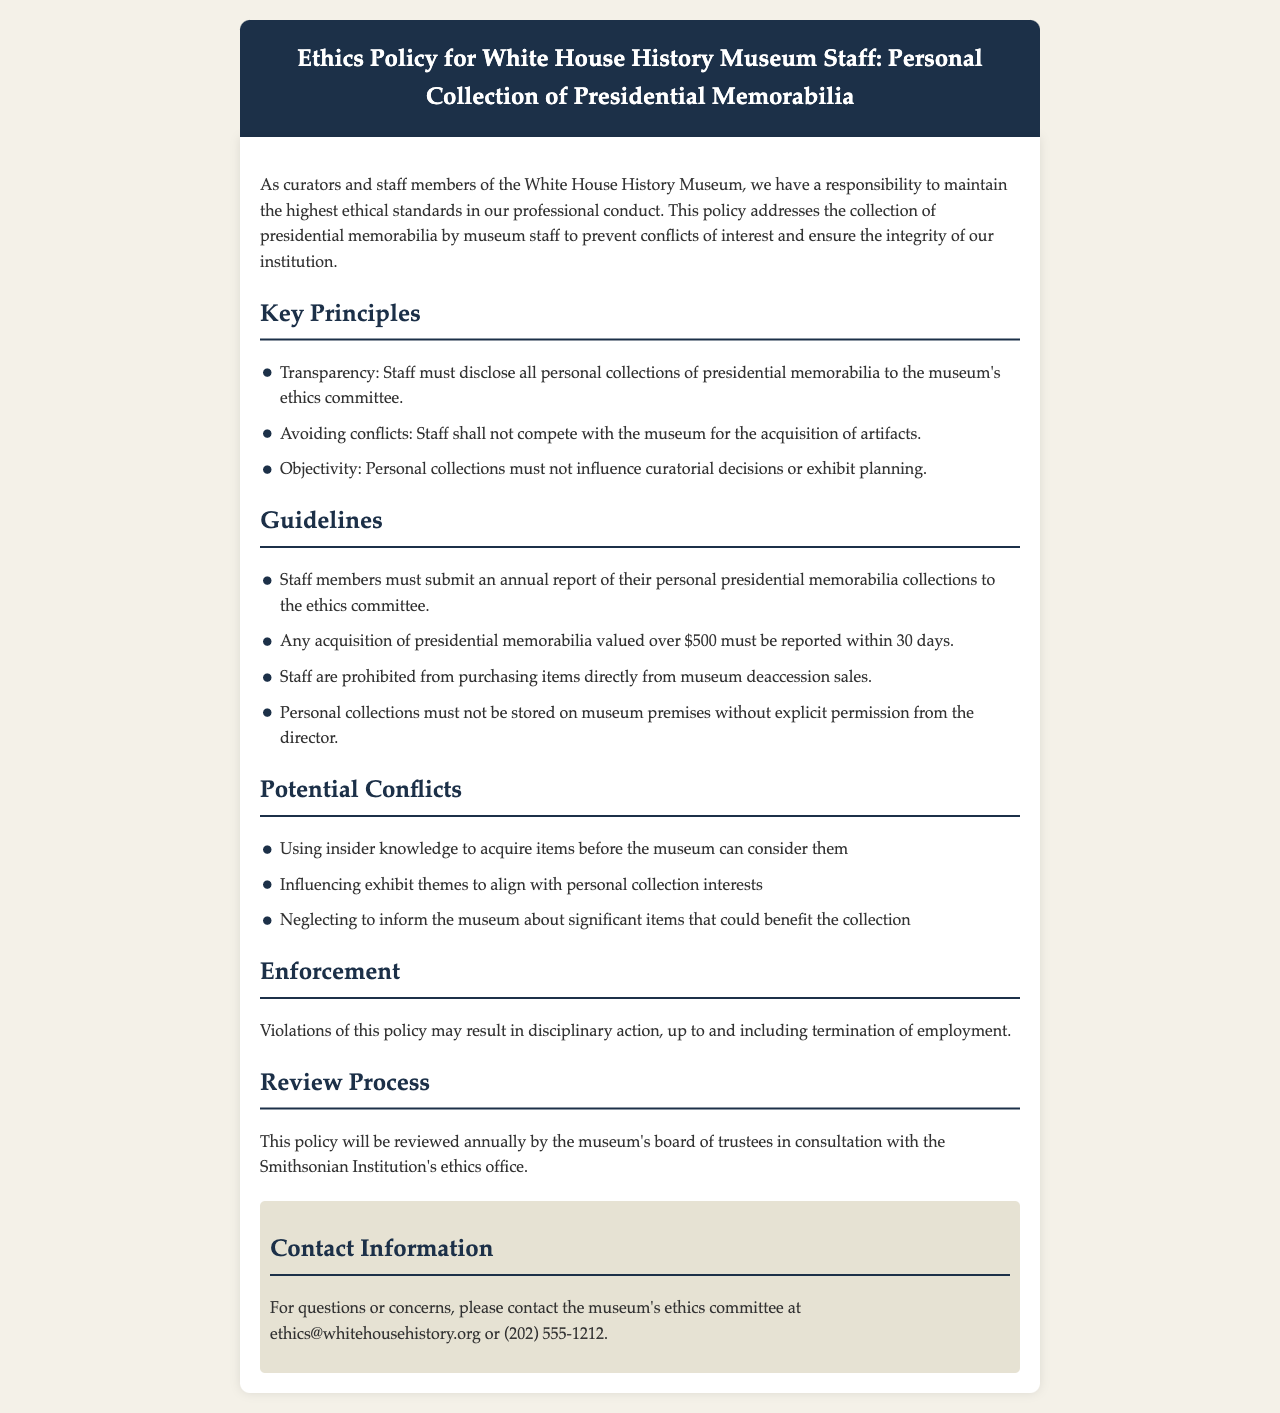What is the title of the document? The title of the document is stated in the header section, which outlines the purpose of the document regarding ethics policy for museum staff.
Answer: Ethics Policy for White House History Museum Staff: Personal Collection of Presidential Memorabilia What is one key principle mentioned in the document? The document outlines several key principles that guide the ethical conduct of staff members, one of which is transparency.
Answer: Transparency How often must staff submit a report of their personal collections? The guidelines section specifies how frequently staff need to report on their collections to maintain ethical standards.
Answer: Annually What is the value threshold for acquisition reporting? The guidelines include a specified threshold above which staff must report acquisitions of presidential memorabilia, which is highlighted very clearly.
Answer: $500 What is the consequence for violating the policy? The enforcement section of the document outlines possible repercussions for failing to comply with the policy.
Answer: Disciplinary action Which committee must staff disclose their collections to? The document clearly states the committee responsible for reviewing personal collections to ensure compliance with the ethics policy.
Answer: Ethics committee How frequently will the policy be reviewed? The review process section indicates how often the policy will be reassessed to ensure its relevance and effectiveness.
Answer: Annually What is prohibited regarding museum deaccession sales? The guidelines mention specific restrictions about acquiring items from museum deaccession sales, contributing to maintaining ethical practices among staff.
Answer: Staff are prohibited from purchasing items directly 